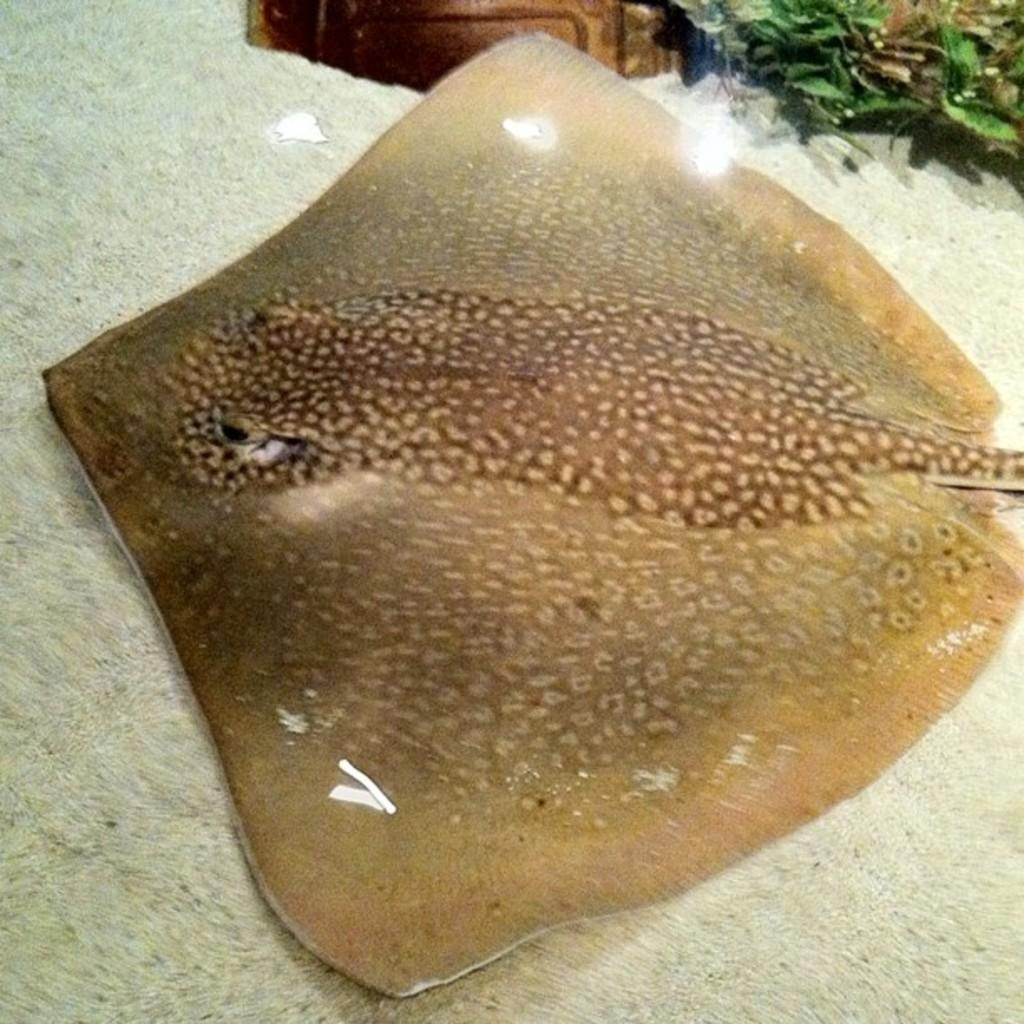What type of animal can be seen in the image? There is an aquatic animal in the image. What is the color of the aquatic animal? The aquatic animal is brown in color. What else can be seen in the image besides the aquatic animal? There are plants visible in the image. What is the color of the object in the image? There is a brown color object in the image. What is the color of the surface in the image? The image has a white color surface. How many squirrels can be seen climbing the plants in the image? There are no squirrels present in the image; it features an aquatic animal and plants. What type of wound can be seen on the aquatic animal in the image? There is no wound visible on the aquatic animal in the image. 